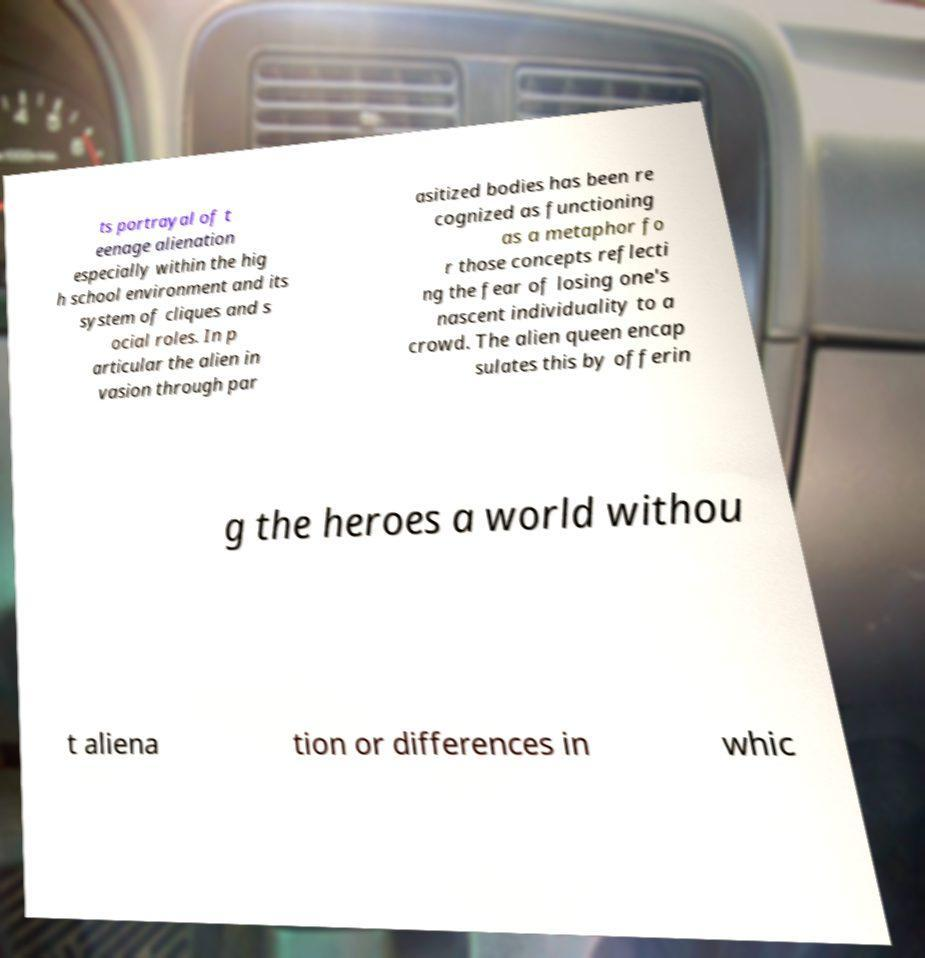For documentation purposes, I need the text within this image transcribed. Could you provide that? ts portrayal of t eenage alienation especially within the hig h school environment and its system of cliques and s ocial roles. In p articular the alien in vasion through par asitized bodies has been re cognized as functioning as a metaphor fo r those concepts reflecti ng the fear of losing one's nascent individuality to a crowd. The alien queen encap sulates this by offerin g the heroes a world withou t aliena tion or differences in whic 